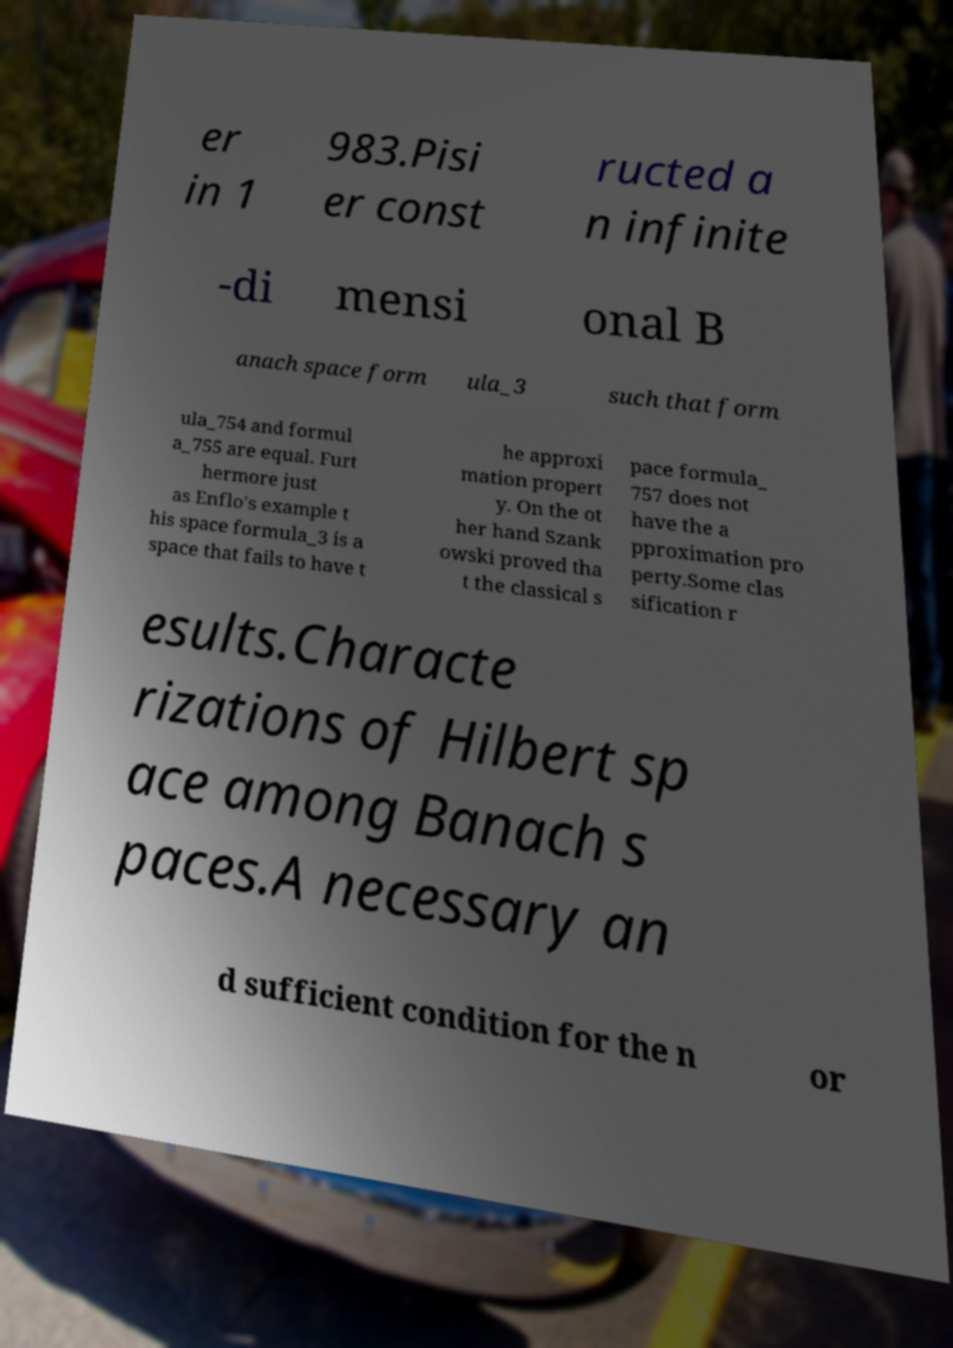Could you extract and type out the text from this image? er in 1 983.Pisi er const ructed a n infinite -di mensi onal B anach space form ula_3 such that form ula_754 and formul a_755 are equal. Furt hermore just as Enflo's example t his space formula_3 is a space that fails to have t he approxi mation propert y. On the ot her hand Szank owski proved tha t the classical s pace formula_ 757 does not have the a pproximation pro perty.Some clas sification r esults.Characte rizations of Hilbert sp ace among Banach s paces.A necessary an d sufficient condition for the n or 